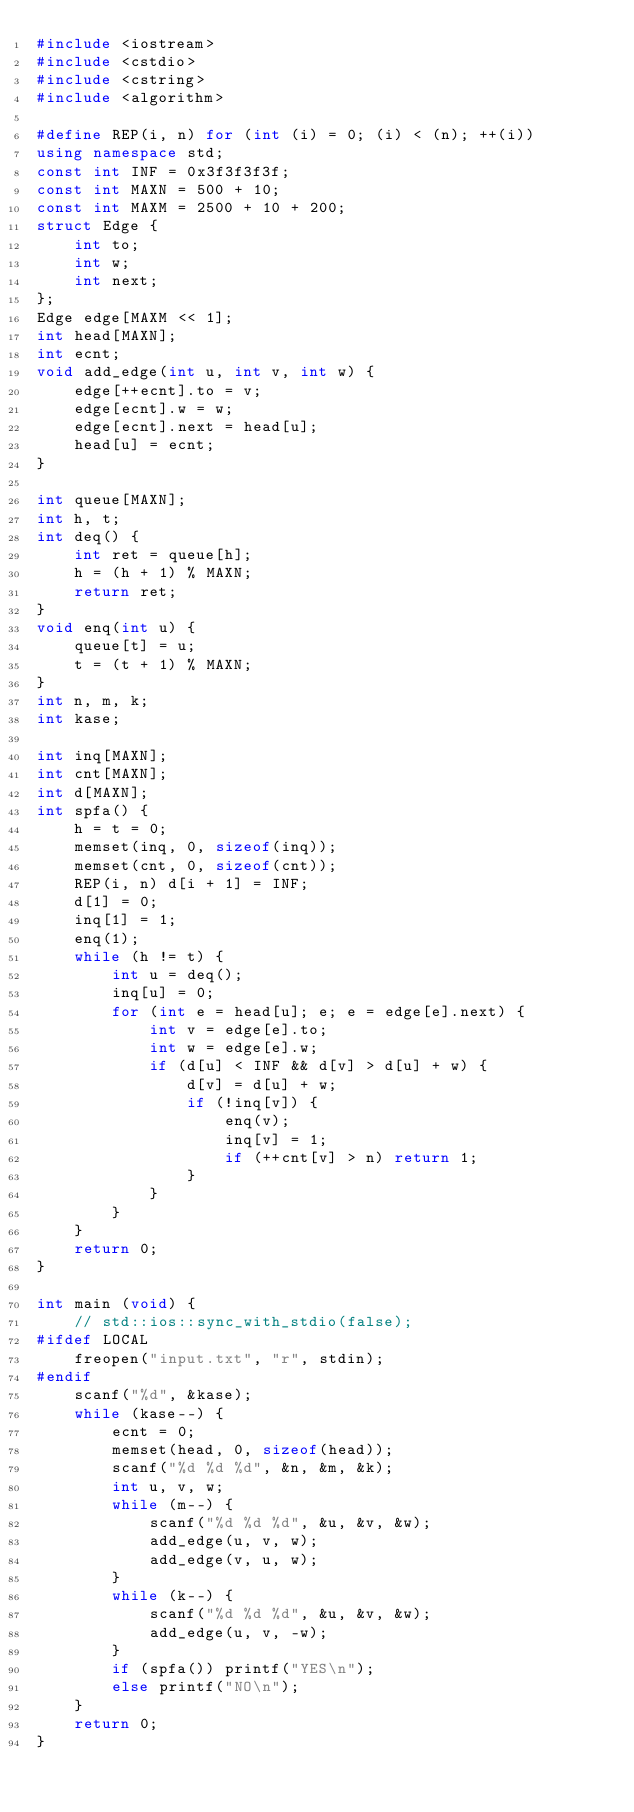<code> <loc_0><loc_0><loc_500><loc_500><_C++_>#include <iostream>
#include <cstdio>
#include <cstring>
#include <algorithm>

#define REP(i, n) for (int (i) = 0; (i) < (n); ++(i))
using namespace std;
const int INF = 0x3f3f3f3f;
const int MAXN = 500 + 10;
const int MAXM = 2500 + 10 + 200;
struct Edge {
    int to;
    int w;
    int next;
};
Edge edge[MAXM << 1];
int head[MAXN];
int ecnt;
void add_edge(int u, int v, int w) {
    edge[++ecnt].to = v;
    edge[ecnt].w = w;
    edge[ecnt].next = head[u];
    head[u] = ecnt;
}

int queue[MAXN];
int h, t;
int deq() {
    int ret = queue[h];
    h = (h + 1) % MAXN;
    return ret;
}
void enq(int u) {
    queue[t] = u;
    t = (t + 1) % MAXN;
}
int n, m, k;
int kase;

int inq[MAXN];
int cnt[MAXN];
int d[MAXN];
int spfa() {
    h = t = 0;
    memset(inq, 0, sizeof(inq));
    memset(cnt, 0, sizeof(cnt));
    REP(i, n) d[i + 1] = INF;
    d[1] = 0;
    inq[1] = 1;
    enq(1);
    while (h != t) {
        int u = deq();
        inq[u] = 0;
        for (int e = head[u]; e; e = edge[e].next) {
            int v = edge[e].to;
            int w = edge[e].w;
            if (d[u] < INF && d[v] > d[u] + w) {
                d[v] = d[u] + w;
                if (!inq[v]) {
                    enq(v);
                    inq[v] = 1;
                    if (++cnt[v] > n) return 1;
                }
            }
        }
    }
    return 0;
}

int main (void) {
    // std::ios::sync_with_stdio(false);
#ifdef LOCAL
    freopen("input.txt", "r", stdin);
#endif
    scanf("%d", &kase);
    while (kase--) {
        ecnt = 0;
        memset(head, 0, sizeof(head));
        scanf("%d %d %d", &n, &m, &k);
        int u, v, w;
        while (m--) {
            scanf("%d %d %d", &u, &v, &w);
            add_edge(u, v, w);
            add_edge(v, u, w);
        }
        while (k--) {
            scanf("%d %d %d", &u, &v, &w);
            add_edge(u, v, -w);
        }
        if (spfa()) printf("YES\n");
        else printf("NO\n");
    }
    return 0;
}</code> 